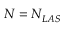Convert formula to latex. <formula><loc_0><loc_0><loc_500><loc_500>N = N _ { L A S }</formula> 